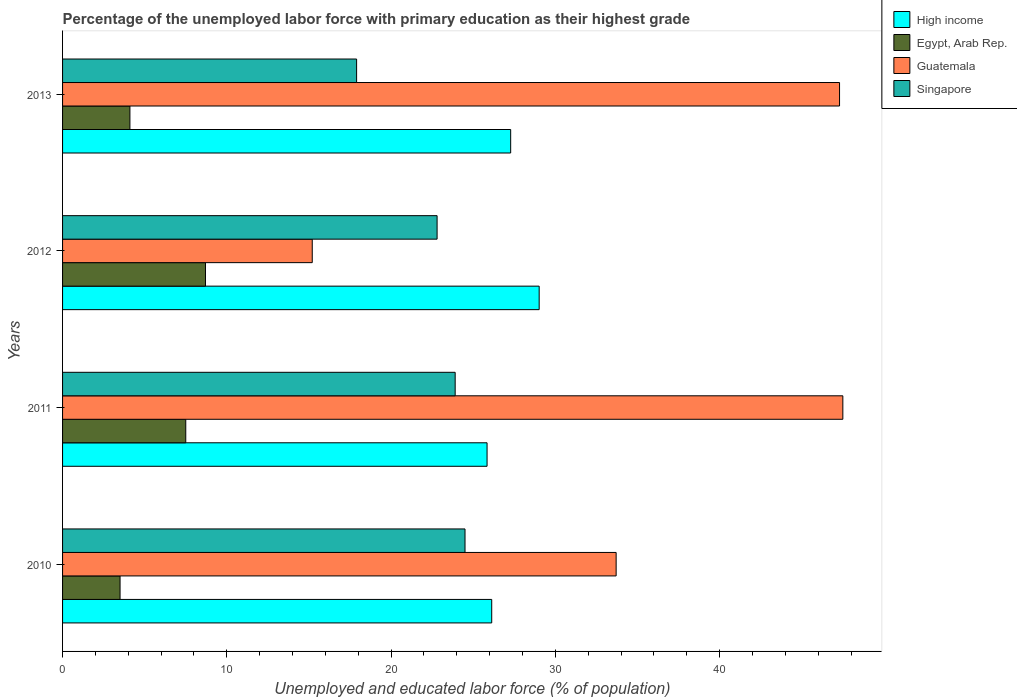Are the number of bars per tick equal to the number of legend labels?
Your answer should be compact. Yes. How many bars are there on the 2nd tick from the bottom?
Offer a very short reply. 4. What is the label of the 2nd group of bars from the top?
Your answer should be compact. 2012. In how many cases, is the number of bars for a given year not equal to the number of legend labels?
Offer a very short reply. 0. Across all years, what is the maximum percentage of the unemployed labor force with primary education in High income?
Your answer should be compact. 29.01. Across all years, what is the minimum percentage of the unemployed labor force with primary education in High income?
Your answer should be very brief. 25.84. In which year was the percentage of the unemployed labor force with primary education in Guatemala maximum?
Your answer should be compact. 2011. What is the total percentage of the unemployed labor force with primary education in Egypt, Arab Rep. in the graph?
Give a very brief answer. 23.8. What is the difference between the percentage of the unemployed labor force with primary education in Singapore in 2010 and that in 2011?
Make the answer very short. 0.6. What is the difference between the percentage of the unemployed labor force with primary education in Egypt, Arab Rep. in 2010 and the percentage of the unemployed labor force with primary education in Singapore in 2011?
Keep it short and to the point. -20.4. What is the average percentage of the unemployed labor force with primary education in Guatemala per year?
Your answer should be compact. 35.92. In the year 2012, what is the difference between the percentage of the unemployed labor force with primary education in Singapore and percentage of the unemployed labor force with primary education in High income?
Offer a very short reply. -6.21. In how many years, is the percentage of the unemployed labor force with primary education in Singapore greater than 30 %?
Keep it short and to the point. 0. What is the ratio of the percentage of the unemployed labor force with primary education in High income in 2011 to that in 2013?
Ensure brevity in your answer.  0.95. What is the difference between the highest and the second highest percentage of the unemployed labor force with primary education in Singapore?
Make the answer very short. 0.6. What is the difference between the highest and the lowest percentage of the unemployed labor force with primary education in Guatemala?
Provide a short and direct response. 32.3. Is the sum of the percentage of the unemployed labor force with primary education in Singapore in 2011 and 2013 greater than the maximum percentage of the unemployed labor force with primary education in High income across all years?
Keep it short and to the point. Yes. What does the 3rd bar from the top in 2012 represents?
Your answer should be compact. Egypt, Arab Rep. What does the 4th bar from the bottom in 2013 represents?
Offer a terse response. Singapore. Is it the case that in every year, the sum of the percentage of the unemployed labor force with primary education in Guatemala and percentage of the unemployed labor force with primary education in Singapore is greater than the percentage of the unemployed labor force with primary education in High income?
Offer a very short reply. Yes. How many bars are there?
Offer a very short reply. 16. How many years are there in the graph?
Keep it short and to the point. 4. What is the difference between two consecutive major ticks on the X-axis?
Make the answer very short. 10. Are the values on the major ticks of X-axis written in scientific E-notation?
Provide a short and direct response. No. Where does the legend appear in the graph?
Give a very brief answer. Top right. What is the title of the graph?
Ensure brevity in your answer.  Percentage of the unemployed labor force with primary education as their highest grade. What is the label or title of the X-axis?
Your answer should be compact. Unemployed and educated labor force (% of population). What is the label or title of the Y-axis?
Keep it short and to the point. Years. What is the Unemployed and educated labor force (% of population) of High income in 2010?
Ensure brevity in your answer.  26.13. What is the Unemployed and educated labor force (% of population) of Egypt, Arab Rep. in 2010?
Keep it short and to the point. 3.5. What is the Unemployed and educated labor force (% of population) in Guatemala in 2010?
Provide a succinct answer. 33.7. What is the Unemployed and educated labor force (% of population) of High income in 2011?
Provide a succinct answer. 25.84. What is the Unemployed and educated labor force (% of population) in Guatemala in 2011?
Your answer should be very brief. 47.5. What is the Unemployed and educated labor force (% of population) in Singapore in 2011?
Make the answer very short. 23.9. What is the Unemployed and educated labor force (% of population) in High income in 2012?
Offer a terse response. 29.01. What is the Unemployed and educated labor force (% of population) in Egypt, Arab Rep. in 2012?
Your answer should be very brief. 8.7. What is the Unemployed and educated labor force (% of population) of Guatemala in 2012?
Keep it short and to the point. 15.2. What is the Unemployed and educated labor force (% of population) of Singapore in 2012?
Ensure brevity in your answer.  22.8. What is the Unemployed and educated labor force (% of population) of High income in 2013?
Offer a terse response. 27.28. What is the Unemployed and educated labor force (% of population) of Egypt, Arab Rep. in 2013?
Ensure brevity in your answer.  4.1. What is the Unemployed and educated labor force (% of population) in Guatemala in 2013?
Give a very brief answer. 47.3. What is the Unemployed and educated labor force (% of population) in Singapore in 2013?
Offer a very short reply. 17.9. Across all years, what is the maximum Unemployed and educated labor force (% of population) of High income?
Your answer should be compact. 29.01. Across all years, what is the maximum Unemployed and educated labor force (% of population) of Egypt, Arab Rep.?
Offer a terse response. 8.7. Across all years, what is the maximum Unemployed and educated labor force (% of population) in Guatemala?
Your answer should be very brief. 47.5. Across all years, what is the minimum Unemployed and educated labor force (% of population) in High income?
Keep it short and to the point. 25.84. Across all years, what is the minimum Unemployed and educated labor force (% of population) of Guatemala?
Offer a very short reply. 15.2. Across all years, what is the minimum Unemployed and educated labor force (% of population) in Singapore?
Keep it short and to the point. 17.9. What is the total Unemployed and educated labor force (% of population) of High income in the graph?
Provide a succinct answer. 108.26. What is the total Unemployed and educated labor force (% of population) of Egypt, Arab Rep. in the graph?
Provide a succinct answer. 23.8. What is the total Unemployed and educated labor force (% of population) of Guatemala in the graph?
Make the answer very short. 143.7. What is the total Unemployed and educated labor force (% of population) of Singapore in the graph?
Provide a short and direct response. 89.1. What is the difference between the Unemployed and educated labor force (% of population) in High income in 2010 and that in 2011?
Your response must be concise. 0.28. What is the difference between the Unemployed and educated labor force (% of population) in Singapore in 2010 and that in 2011?
Make the answer very short. 0.6. What is the difference between the Unemployed and educated labor force (% of population) in High income in 2010 and that in 2012?
Offer a very short reply. -2.89. What is the difference between the Unemployed and educated labor force (% of population) in Egypt, Arab Rep. in 2010 and that in 2012?
Give a very brief answer. -5.2. What is the difference between the Unemployed and educated labor force (% of population) in Singapore in 2010 and that in 2012?
Keep it short and to the point. 1.7. What is the difference between the Unemployed and educated labor force (% of population) of High income in 2010 and that in 2013?
Offer a very short reply. -1.15. What is the difference between the Unemployed and educated labor force (% of population) in Guatemala in 2010 and that in 2013?
Provide a succinct answer. -13.6. What is the difference between the Unemployed and educated labor force (% of population) of Singapore in 2010 and that in 2013?
Offer a terse response. 6.6. What is the difference between the Unemployed and educated labor force (% of population) in High income in 2011 and that in 2012?
Offer a very short reply. -3.17. What is the difference between the Unemployed and educated labor force (% of population) of Egypt, Arab Rep. in 2011 and that in 2012?
Your answer should be compact. -1.2. What is the difference between the Unemployed and educated labor force (% of population) of Guatemala in 2011 and that in 2012?
Make the answer very short. 32.3. What is the difference between the Unemployed and educated labor force (% of population) of Singapore in 2011 and that in 2012?
Give a very brief answer. 1.1. What is the difference between the Unemployed and educated labor force (% of population) of High income in 2011 and that in 2013?
Your response must be concise. -1.44. What is the difference between the Unemployed and educated labor force (% of population) of Guatemala in 2011 and that in 2013?
Keep it short and to the point. 0.2. What is the difference between the Unemployed and educated labor force (% of population) of Singapore in 2011 and that in 2013?
Provide a succinct answer. 6. What is the difference between the Unemployed and educated labor force (% of population) of High income in 2012 and that in 2013?
Offer a terse response. 1.74. What is the difference between the Unemployed and educated labor force (% of population) in Egypt, Arab Rep. in 2012 and that in 2013?
Your answer should be compact. 4.6. What is the difference between the Unemployed and educated labor force (% of population) of Guatemala in 2012 and that in 2013?
Provide a short and direct response. -32.1. What is the difference between the Unemployed and educated labor force (% of population) of High income in 2010 and the Unemployed and educated labor force (% of population) of Egypt, Arab Rep. in 2011?
Offer a terse response. 18.62. What is the difference between the Unemployed and educated labor force (% of population) of High income in 2010 and the Unemployed and educated labor force (% of population) of Guatemala in 2011?
Provide a short and direct response. -21.38. What is the difference between the Unemployed and educated labor force (% of population) in High income in 2010 and the Unemployed and educated labor force (% of population) in Singapore in 2011?
Your answer should be very brief. 2.23. What is the difference between the Unemployed and educated labor force (% of population) in Egypt, Arab Rep. in 2010 and the Unemployed and educated labor force (% of population) in Guatemala in 2011?
Your response must be concise. -44. What is the difference between the Unemployed and educated labor force (% of population) of Egypt, Arab Rep. in 2010 and the Unemployed and educated labor force (% of population) of Singapore in 2011?
Your response must be concise. -20.4. What is the difference between the Unemployed and educated labor force (% of population) in High income in 2010 and the Unemployed and educated labor force (% of population) in Egypt, Arab Rep. in 2012?
Ensure brevity in your answer.  17.43. What is the difference between the Unemployed and educated labor force (% of population) of High income in 2010 and the Unemployed and educated labor force (% of population) of Guatemala in 2012?
Give a very brief answer. 10.93. What is the difference between the Unemployed and educated labor force (% of population) in High income in 2010 and the Unemployed and educated labor force (% of population) in Singapore in 2012?
Your answer should be compact. 3.33. What is the difference between the Unemployed and educated labor force (% of population) in Egypt, Arab Rep. in 2010 and the Unemployed and educated labor force (% of population) in Guatemala in 2012?
Ensure brevity in your answer.  -11.7. What is the difference between the Unemployed and educated labor force (% of population) in Egypt, Arab Rep. in 2010 and the Unemployed and educated labor force (% of population) in Singapore in 2012?
Ensure brevity in your answer.  -19.3. What is the difference between the Unemployed and educated labor force (% of population) of Guatemala in 2010 and the Unemployed and educated labor force (% of population) of Singapore in 2012?
Offer a terse response. 10.9. What is the difference between the Unemployed and educated labor force (% of population) in High income in 2010 and the Unemployed and educated labor force (% of population) in Egypt, Arab Rep. in 2013?
Keep it short and to the point. 22.02. What is the difference between the Unemployed and educated labor force (% of population) in High income in 2010 and the Unemployed and educated labor force (% of population) in Guatemala in 2013?
Make the answer very short. -21.18. What is the difference between the Unemployed and educated labor force (% of population) of High income in 2010 and the Unemployed and educated labor force (% of population) of Singapore in 2013?
Provide a succinct answer. 8.22. What is the difference between the Unemployed and educated labor force (% of population) in Egypt, Arab Rep. in 2010 and the Unemployed and educated labor force (% of population) in Guatemala in 2013?
Provide a succinct answer. -43.8. What is the difference between the Unemployed and educated labor force (% of population) in Egypt, Arab Rep. in 2010 and the Unemployed and educated labor force (% of population) in Singapore in 2013?
Ensure brevity in your answer.  -14.4. What is the difference between the Unemployed and educated labor force (% of population) of High income in 2011 and the Unemployed and educated labor force (% of population) of Egypt, Arab Rep. in 2012?
Make the answer very short. 17.14. What is the difference between the Unemployed and educated labor force (% of population) of High income in 2011 and the Unemployed and educated labor force (% of population) of Guatemala in 2012?
Offer a very short reply. 10.64. What is the difference between the Unemployed and educated labor force (% of population) of High income in 2011 and the Unemployed and educated labor force (% of population) of Singapore in 2012?
Offer a terse response. 3.04. What is the difference between the Unemployed and educated labor force (% of population) in Egypt, Arab Rep. in 2011 and the Unemployed and educated labor force (% of population) in Singapore in 2012?
Your answer should be very brief. -15.3. What is the difference between the Unemployed and educated labor force (% of population) in Guatemala in 2011 and the Unemployed and educated labor force (% of population) in Singapore in 2012?
Offer a terse response. 24.7. What is the difference between the Unemployed and educated labor force (% of population) of High income in 2011 and the Unemployed and educated labor force (% of population) of Egypt, Arab Rep. in 2013?
Your answer should be very brief. 21.74. What is the difference between the Unemployed and educated labor force (% of population) in High income in 2011 and the Unemployed and educated labor force (% of population) in Guatemala in 2013?
Ensure brevity in your answer.  -21.46. What is the difference between the Unemployed and educated labor force (% of population) in High income in 2011 and the Unemployed and educated labor force (% of population) in Singapore in 2013?
Give a very brief answer. 7.94. What is the difference between the Unemployed and educated labor force (% of population) in Egypt, Arab Rep. in 2011 and the Unemployed and educated labor force (% of population) in Guatemala in 2013?
Your answer should be compact. -39.8. What is the difference between the Unemployed and educated labor force (% of population) in Egypt, Arab Rep. in 2011 and the Unemployed and educated labor force (% of population) in Singapore in 2013?
Give a very brief answer. -10.4. What is the difference between the Unemployed and educated labor force (% of population) in Guatemala in 2011 and the Unemployed and educated labor force (% of population) in Singapore in 2013?
Give a very brief answer. 29.6. What is the difference between the Unemployed and educated labor force (% of population) of High income in 2012 and the Unemployed and educated labor force (% of population) of Egypt, Arab Rep. in 2013?
Your answer should be compact. 24.91. What is the difference between the Unemployed and educated labor force (% of population) of High income in 2012 and the Unemployed and educated labor force (% of population) of Guatemala in 2013?
Your answer should be very brief. -18.29. What is the difference between the Unemployed and educated labor force (% of population) in High income in 2012 and the Unemployed and educated labor force (% of population) in Singapore in 2013?
Make the answer very short. 11.11. What is the difference between the Unemployed and educated labor force (% of population) of Egypt, Arab Rep. in 2012 and the Unemployed and educated labor force (% of population) of Guatemala in 2013?
Ensure brevity in your answer.  -38.6. What is the difference between the Unemployed and educated labor force (% of population) of Egypt, Arab Rep. in 2012 and the Unemployed and educated labor force (% of population) of Singapore in 2013?
Your answer should be compact. -9.2. What is the difference between the Unemployed and educated labor force (% of population) in Guatemala in 2012 and the Unemployed and educated labor force (% of population) in Singapore in 2013?
Your answer should be very brief. -2.7. What is the average Unemployed and educated labor force (% of population) of High income per year?
Offer a very short reply. 27.07. What is the average Unemployed and educated labor force (% of population) in Egypt, Arab Rep. per year?
Give a very brief answer. 5.95. What is the average Unemployed and educated labor force (% of population) of Guatemala per year?
Offer a terse response. 35.92. What is the average Unemployed and educated labor force (% of population) of Singapore per year?
Your answer should be very brief. 22.27. In the year 2010, what is the difference between the Unemployed and educated labor force (% of population) of High income and Unemployed and educated labor force (% of population) of Egypt, Arab Rep.?
Give a very brief answer. 22.62. In the year 2010, what is the difference between the Unemployed and educated labor force (% of population) of High income and Unemployed and educated labor force (% of population) of Guatemala?
Provide a succinct answer. -7.58. In the year 2010, what is the difference between the Unemployed and educated labor force (% of population) of High income and Unemployed and educated labor force (% of population) of Singapore?
Provide a short and direct response. 1.62. In the year 2010, what is the difference between the Unemployed and educated labor force (% of population) in Egypt, Arab Rep. and Unemployed and educated labor force (% of population) in Guatemala?
Your response must be concise. -30.2. In the year 2010, what is the difference between the Unemployed and educated labor force (% of population) of Egypt, Arab Rep. and Unemployed and educated labor force (% of population) of Singapore?
Your answer should be very brief. -21. In the year 2010, what is the difference between the Unemployed and educated labor force (% of population) in Guatemala and Unemployed and educated labor force (% of population) in Singapore?
Give a very brief answer. 9.2. In the year 2011, what is the difference between the Unemployed and educated labor force (% of population) in High income and Unemployed and educated labor force (% of population) in Egypt, Arab Rep.?
Keep it short and to the point. 18.34. In the year 2011, what is the difference between the Unemployed and educated labor force (% of population) in High income and Unemployed and educated labor force (% of population) in Guatemala?
Make the answer very short. -21.66. In the year 2011, what is the difference between the Unemployed and educated labor force (% of population) in High income and Unemployed and educated labor force (% of population) in Singapore?
Your answer should be very brief. 1.94. In the year 2011, what is the difference between the Unemployed and educated labor force (% of population) of Egypt, Arab Rep. and Unemployed and educated labor force (% of population) of Guatemala?
Make the answer very short. -40. In the year 2011, what is the difference between the Unemployed and educated labor force (% of population) of Egypt, Arab Rep. and Unemployed and educated labor force (% of population) of Singapore?
Offer a terse response. -16.4. In the year 2011, what is the difference between the Unemployed and educated labor force (% of population) in Guatemala and Unemployed and educated labor force (% of population) in Singapore?
Give a very brief answer. 23.6. In the year 2012, what is the difference between the Unemployed and educated labor force (% of population) of High income and Unemployed and educated labor force (% of population) of Egypt, Arab Rep.?
Make the answer very short. 20.31. In the year 2012, what is the difference between the Unemployed and educated labor force (% of population) in High income and Unemployed and educated labor force (% of population) in Guatemala?
Provide a short and direct response. 13.81. In the year 2012, what is the difference between the Unemployed and educated labor force (% of population) in High income and Unemployed and educated labor force (% of population) in Singapore?
Your response must be concise. 6.21. In the year 2012, what is the difference between the Unemployed and educated labor force (% of population) of Egypt, Arab Rep. and Unemployed and educated labor force (% of population) of Singapore?
Offer a very short reply. -14.1. In the year 2012, what is the difference between the Unemployed and educated labor force (% of population) of Guatemala and Unemployed and educated labor force (% of population) of Singapore?
Your answer should be compact. -7.6. In the year 2013, what is the difference between the Unemployed and educated labor force (% of population) of High income and Unemployed and educated labor force (% of population) of Egypt, Arab Rep.?
Offer a terse response. 23.18. In the year 2013, what is the difference between the Unemployed and educated labor force (% of population) of High income and Unemployed and educated labor force (% of population) of Guatemala?
Provide a short and direct response. -20.02. In the year 2013, what is the difference between the Unemployed and educated labor force (% of population) in High income and Unemployed and educated labor force (% of population) in Singapore?
Offer a terse response. 9.38. In the year 2013, what is the difference between the Unemployed and educated labor force (% of population) in Egypt, Arab Rep. and Unemployed and educated labor force (% of population) in Guatemala?
Provide a short and direct response. -43.2. In the year 2013, what is the difference between the Unemployed and educated labor force (% of population) in Guatemala and Unemployed and educated labor force (% of population) in Singapore?
Make the answer very short. 29.4. What is the ratio of the Unemployed and educated labor force (% of population) of High income in 2010 to that in 2011?
Give a very brief answer. 1.01. What is the ratio of the Unemployed and educated labor force (% of population) of Egypt, Arab Rep. in 2010 to that in 2011?
Your response must be concise. 0.47. What is the ratio of the Unemployed and educated labor force (% of population) in Guatemala in 2010 to that in 2011?
Provide a succinct answer. 0.71. What is the ratio of the Unemployed and educated labor force (% of population) of Singapore in 2010 to that in 2011?
Give a very brief answer. 1.03. What is the ratio of the Unemployed and educated labor force (% of population) of High income in 2010 to that in 2012?
Provide a succinct answer. 0.9. What is the ratio of the Unemployed and educated labor force (% of population) in Egypt, Arab Rep. in 2010 to that in 2012?
Keep it short and to the point. 0.4. What is the ratio of the Unemployed and educated labor force (% of population) of Guatemala in 2010 to that in 2012?
Provide a succinct answer. 2.22. What is the ratio of the Unemployed and educated labor force (% of population) in Singapore in 2010 to that in 2012?
Provide a succinct answer. 1.07. What is the ratio of the Unemployed and educated labor force (% of population) of High income in 2010 to that in 2013?
Offer a terse response. 0.96. What is the ratio of the Unemployed and educated labor force (% of population) of Egypt, Arab Rep. in 2010 to that in 2013?
Your response must be concise. 0.85. What is the ratio of the Unemployed and educated labor force (% of population) in Guatemala in 2010 to that in 2013?
Give a very brief answer. 0.71. What is the ratio of the Unemployed and educated labor force (% of population) in Singapore in 2010 to that in 2013?
Your response must be concise. 1.37. What is the ratio of the Unemployed and educated labor force (% of population) in High income in 2011 to that in 2012?
Offer a very short reply. 0.89. What is the ratio of the Unemployed and educated labor force (% of population) of Egypt, Arab Rep. in 2011 to that in 2012?
Keep it short and to the point. 0.86. What is the ratio of the Unemployed and educated labor force (% of population) of Guatemala in 2011 to that in 2012?
Ensure brevity in your answer.  3.12. What is the ratio of the Unemployed and educated labor force (% of population) of Singapore in 2011 to that in 2012?
Give a very brief answer. 1.05. What is the ratio of the Unemployed and educated labor force (% of population) of High income in 2011 to that in 2013?
Ensure brevity in your answer.  0.95. What is the ratio of the Unemployed and educated labor force (% of population) of Egypt, Arab Rep. in 2011 to that in 2013?
Provide a succinct answer. 1.83. What is the ratio of the Unemployed and educated labor force (% of population) in Guatemala in 2011 to that in 2013?
Keep it short and to the point. 1. What is the ratio of the Unemployed and educated labor force (% of population) of Singapore in 2011 to that in 2013?
Your answer should be compact. 1.34. What is the ratio of the Unemployed and educated labor force (% of population) of High income in 2012 to that in 2013?
Keep it short and to the point. 1.06. What is the ratio of the Unemployed and educated labor force (% of population) of Egypt, Arab Rep. in 2012 to that in 2013?
Offer a very short reply. 2.12. What is the ratio of the Unemployed and educated labor force (% of population) of Guatemala in 2012 to that in 2013?
Provide a succinct answer. 0.32. What is the ratio of the Unemployed and educated labor force (% of population) of Singapore in 2012 to that in 2013?
Offer a terse response. 1.27. What is the difference between the highest and the second highest Unemployed and educated labor force (% of population) in High income?
Provide a short and direct response. 1.74. What is the difference between the highest and the second highest Unemployed and educated labor force (% of population) in Egypt, Arab Rep.?
Keep it short and to the point. 1.2. What is the difference between the highest and the second highest Unemployed and educated labor force (% of population) in Guatemala?
Offer a terse response. 0.2. What is the difference between the highest and the lowest Unemployed and educated labor force (% of population) in High income?
Provide a short and direct response. 3.17. What is the difference between the highest and the lowest Unemployed and educated labor force (% of population) in Egypt, Arab Rep.?
Offer a terse response. 5.2. What is the difference between the highest and the lowest Unemployed and educated labor force (% of population) in Guatemala?
Make the answer very short. 32.3. 